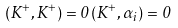Convert formula to latex. <formula><loc_0><loc_0><loc_500><loc_500>( K ^ { + } , K ^ { + } ) = 0 \, ( K ^ { + } , \alpha _ { i } ) = 0</formula> 